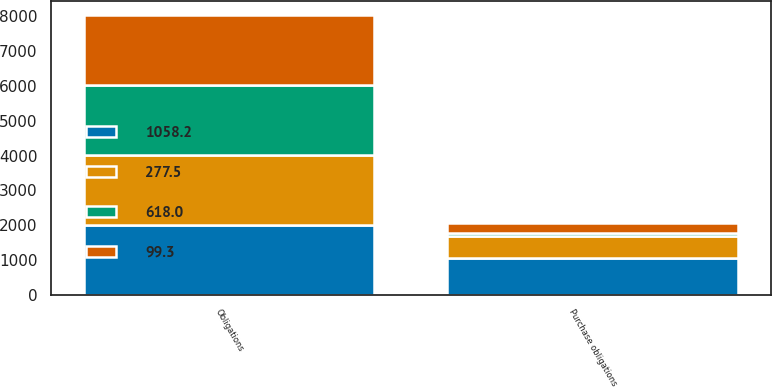<chart> <loc_0><loc_0><loc_500><loc_500><stacked_bar_chart><ecel><fcel>Obligations<fcel>Purchase obligations<nl><fcel>1058.2<fcel>2008<fcel>1058.2<nl><fcel>277.5<fcel>2009<fcel>618<nl><fcel>99.3<fcel>2010<fcel>277.5<nl><fcel>618<fcel>2011<fcel>99.3<nl></chart> 